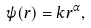<formula> <loc_0><loc_0><loc_500><loc_500>\psi ( r ) = k r ^ { \alpha } ,</formula> 